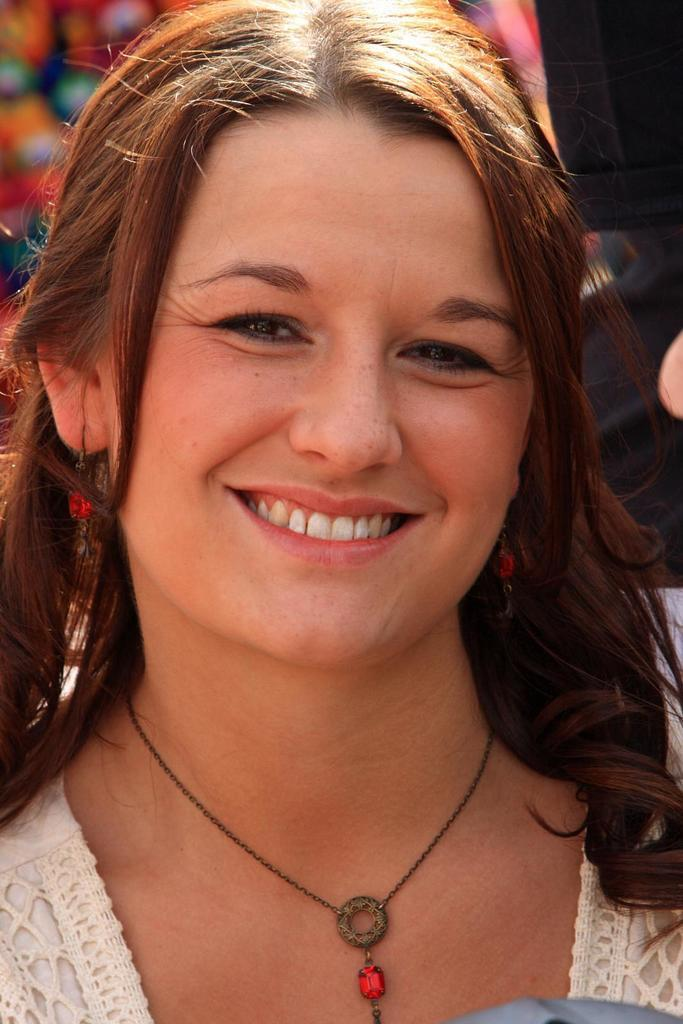Where was the image taken? The image is taken outdoors. Who is present in the image? There is a woman in the image. What is the woman's facial expression? The woman has a smiling face. Can you describe the background of the image? There are two people in the background of the image. What type of marble is being used to create the woman's smile in the image? There is no marble present in the image, and the woman's smile is not created using any type of marble. 